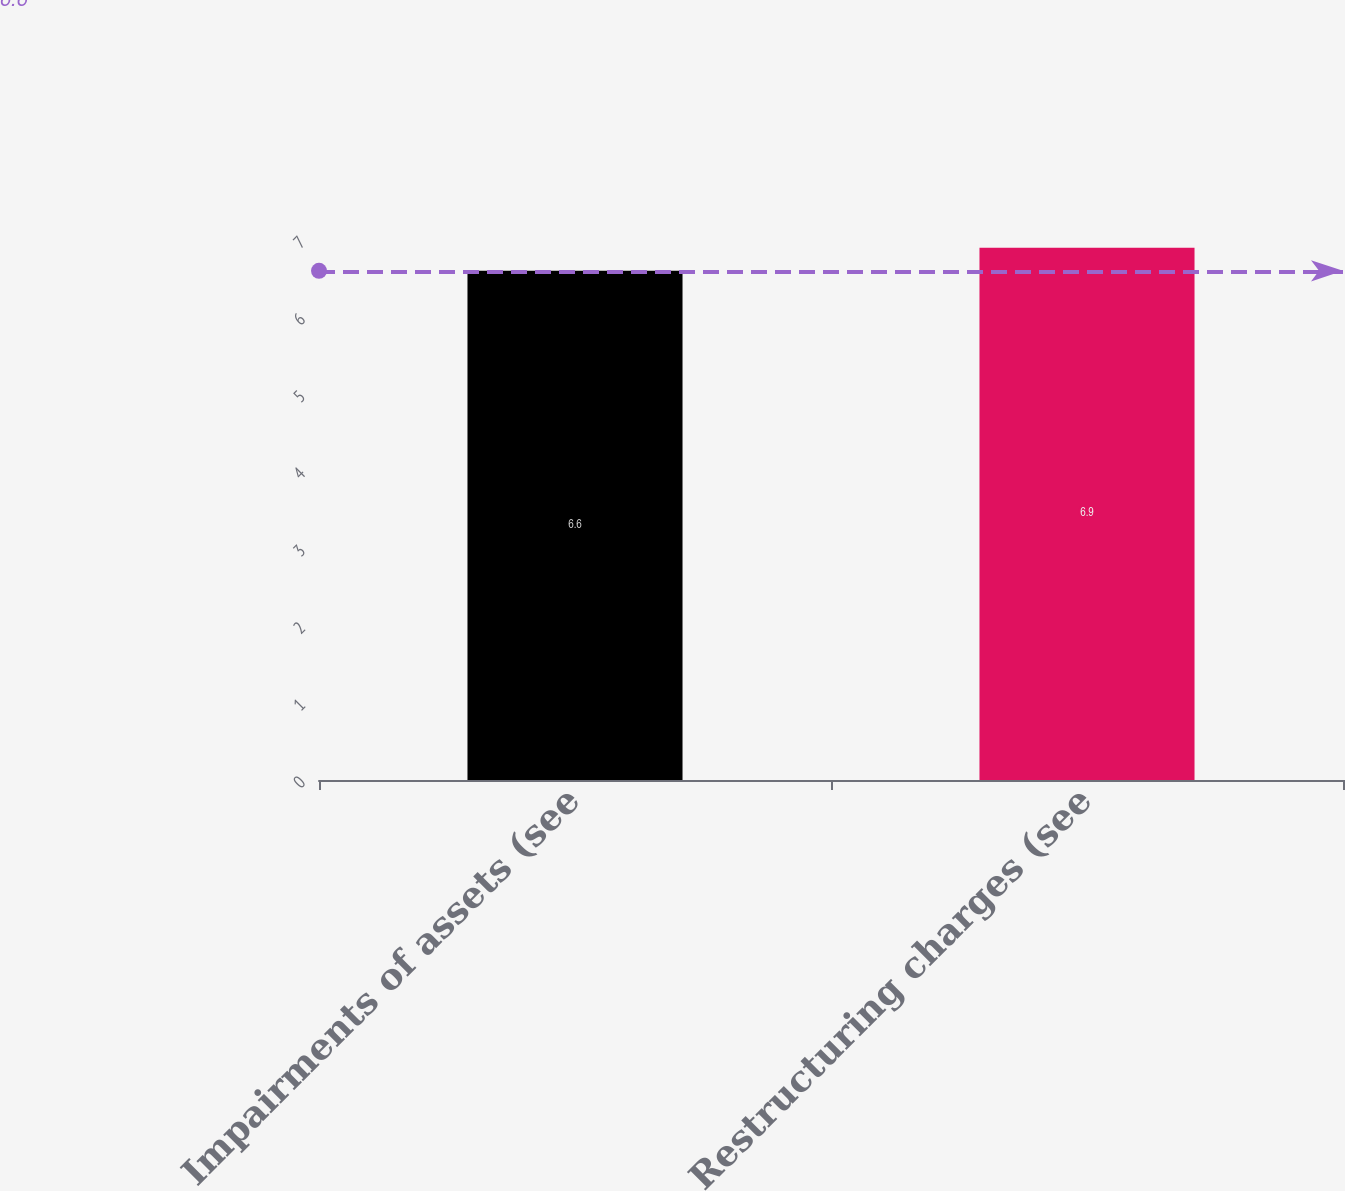Convert chart. <chart><loc_0><loc_0><loc_500><loc_500><bar_chart><fcel>Impairments of assets (see<fcel>Restructuring charges (see<nl><fcel>6.6<fcel>6.9<nl></chart> 